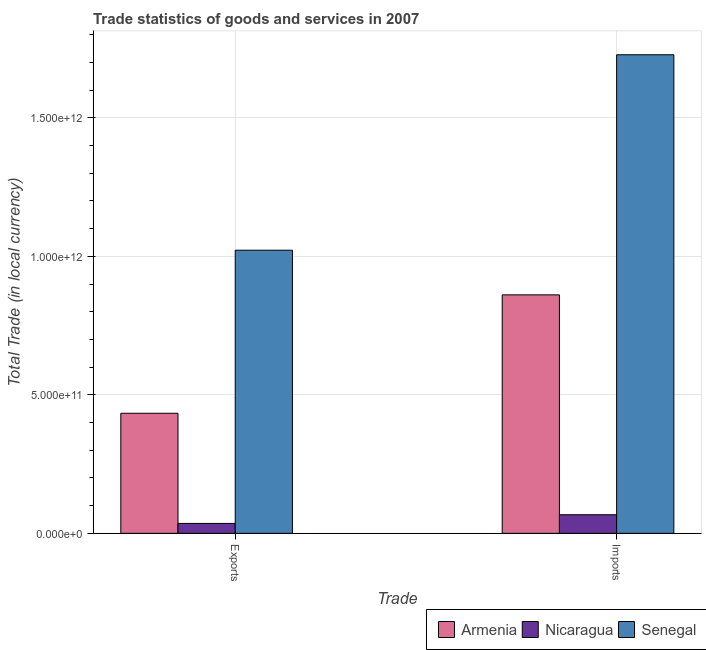How many different coloured bars are there?
Ensure brevity in your answer.  3. How many bars are there on the 2nd tick from the left?
Provide a short and direct response. 3. What is the label of the 1st group of bars from the left?
Your answer should be very brief. Exports. What is the imports of goods and services in Armenia?
Make the answer very short. 8.61e+11. Across all countries, what is the maximum export of goods and services?
Provide a short and direct response. 1.02e+12. Across all countries, what is the minimum export of goods and services?
Offer a terse response. 3.58e+1. In which country was the export of goods and services maximum?
Make the answer very short. Senegal. In which country was the export of goods and services minimum?
Ensure brevity in your answer.  Nicaragua. What is the total export of goods and services in the graph?
Provide a short and direct response. 1.49e+12. What is the difference between the imports of goods and services in Armenia and that in Senegal?
Provide a succinct answer. -8.67e+11. What is the difference between the imports of goods and services in Armenia and the export of goods and services in Senegal?
Your answer should be very brief. -1.61e+11. What is the average imports of goods and services per country?
Offer a very short reply. 8.85e+11. What is the difference between the imports of goods and services and export of goods and services in Senegal?
Your answer should be very brief. 7.06e+11. What is the ratio of the export of goods and services in Nicaragua to that in Senegal?
Provide a short and direct response. 0.04. What does the 1st bar from the left in Exports represents?
Offer a very short reply. Armenia. What does the 2nd bar from the right in Imports represents?
Offer a very short reply. Nicaragua. How many bars are there?
Ensure brevity in your answer.  6. What is the difference between two consecutive major ticks on the Y-axis?
Make the answer very short. 5.00e+11. Are the values on the major ticks of Y-axis written in scientific E-notation?
Provide a succinct answer. Yes. Does the graph contain any zero values?
Provide a succinct answer. No. Does the graph contain grids?
Your response must be concise. Yes. How many legend labels are there?
Ensure brevity in your answer.  3. How are the legend labels stacked?
Give a very brief answer. Horizontal. What is the title of the graph?
Provide a short and direct response. Trade statistics of goods and services in 2007. Does "Indonesia" appear as one of the legend labels in the graph?
Keep it short and to the point. No. What is the label or title of the X-axis?
Ensure brevity in your answer.  Trade. What is the label or title of the Y-axis?
Offer a very short reply. Total Trade (in local currency). What is the Total Trade (in local currency) of Armenia in Exports?
Make the answer very short. 4.33e+11. What is the Total Trade (in local currency) in Nicaragua in Exports?
Offer a terse response. 3.58e+1. What is the Total Trade (in local currency) in Senegal in Exports?
Your answer should be compact. 1.02e+12. What is the Total Trade (in local currency) of Armenia in Imports?
Ensure brevity in your answer.  8.61e+11. What is the Total Trade (in local currency) of Nicaragua in Imports?
Give a very brief answer. 6.72e+1. What is the Total Trade (in local currency) of Senegal in Imports?
Your response must be concise. 1.73e+12. Across all Trade, what is the maximum Total Trade (in local currency) in Armenia?
Offer a very short reply. 8.61e+11. Across all Trade, what is the maximum Total Trade (in local currency) in Nicaragua?
Ensure brevity in your answer.  6.72e+1. Across all Trade, what is the maximum Total Trade (in local currency) in Senegal?
Your answer should be compact. 1.73e+12. Across all Trade, what is the minimum Total Trade (in local currency) of Armenia?
Your answer should be very brief. 4.33e+11. Across all Trade, what is the minimum Total Trade (in local currency) of Nicaragua?
Offer a terse response. 3.58e+1. Across all Trade, what is the minimum Total Trade (in local currency) in Senegal?
Provide a succinct answer. 1.02e+12. What is the total Total Trade (in local currency) in Armenia in the graph?
Offer a terse response. 1.29e+12. What is the total Total Trade (in local currency) of Nicaragua in the graph?
Provide a short and direct response. 1.03e+11. What is the total Total Trade (in local currency) of Senegal in the graph?
Provide a short and direct response. 2.75e+12. What is the difference between the Total Trade (in local currency) in Armenia in Exports and that in Imports?
Your response must be concise. -4.28e+11. What is the difference between the Total Trade (in local currency) in Nicaragua in Exports and that in Imports?
Your response must be concise. -3.14e+1. What is the difference between the Total Trade (in local currency) in Senegal in Exports and that in Imports?
Ensure brevity in your answer.  -7.06e+11. What is the difference between the Total Trade (in local currency) of Armenia in Exports and the Total Trade (in local currency) of Nicaragua in Imports?
Make the answer very short. 3.66e+11. What is the difference between the Total Trade (in local currency) in Armenia in Exports and the Total Trade (in local currency) in Senegal in Imports?
Offer a very short reply. -1.29e+12. What is the difference between the Total Trade (in local currency) of Nicaragua in Exports and the Total Trade (in local currency) of Senegal in Imports?
Your answer should be compact. -1.69e+12. What is the average Total Trade (in local currency) of Armenia per Trade?
Keep it short and to the point. 6.47e+11. What is the average Total Trade (in local currency) of Nicaragua per Trade?
Your answer should be very brief. 5.15e+1. What is the average Total Trade (in local currency) in Senegal per Trade?
Ensure brevity in your answer.  1.37e+12. What is the difference between the Total Trade (in local currency) in Armenia and Total Trade (in local currency) in Nicaragua in Exports?
Your answer should be compact. 3.98e+11. What is the difference between the Total Trade (in local currency) of Armenia and Total Trade (in local currency) of Senegal in Exports?
Make the answer very short. -5.89e+11. What is the difference between the Total Trade (in local currency) in Nicaragua and Total Trade (in local currency) in Senegal in Exports?
Your answer should be very brief. -9.86e+11. What is the difference between the Total Trade (in local currency) in Armenia and Total Trade (in local currency) in Nicaragua in Imports?
Offer a very short reply. 7.94e+11. What is the difference between the Total Trade (in local currency) in Armenia and Total Trade (in local currency) in Senegal in Imports?
Offer a very short reply. -8.67e+11. What is the difference between the Total Trade (in local currency) in Nicaragua and Total Trade (in local currency) in Senegal in Imports?
Your answer should be very brief. -1.66e+12. What is the ratio of the Total Trade (in local currency) of Armenia in Exports to that in Imports?
Keep it short and to the point. 0.5. What is the ratio of the Total Trade (in local currency) in Nicaragua in Exports to that in Imports?
Give a very brief answer. 0.53. What is the ratio of the Total Trade (in local currency) of Senegal in Exports to that in Imports?
Provide a succinct answer. 0.59. What is the difference between the highest and the second highest Total Trade (in local currency) of Armenia?
Provide a succinct answer. 4.28e+11. What is the difference between the highest and the second highest Total Trade (in local currency) of Nicaragua?
Make the answer very short. 3.14e+1. What is the difference between the highest and the second highest Total Trade (in local currency) of Senegal?
Provide a succinct answer. 7.06e+11. What is the difference between the highest and the lowest Total Trade (in local currency) of Armenia?
Give a very brief answer. 4.28e+11. What is the difference between the highest and the lowest Total Trade (in local currency) of Nicaragua?
Offer a terse response. 3.14e+1. What is the difference between the highest and the lowest Total Trade (in local currency) of Senegal?
Make the answer very short. 7.06e+11. 